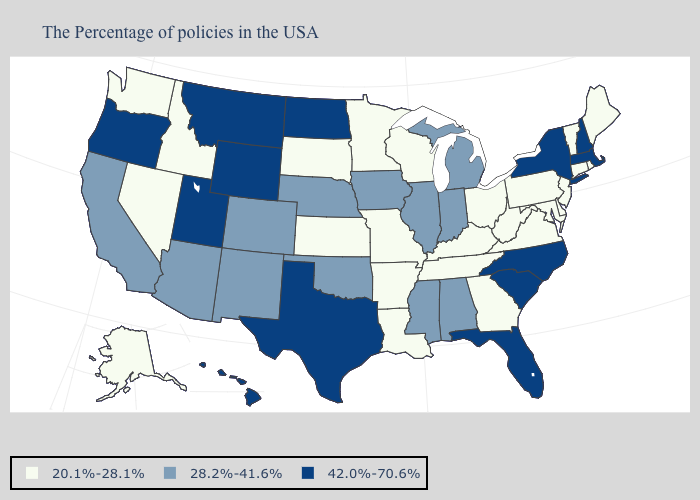Name the states that have a value in the range 20.1%-28.1%?
Concise answer only. Maine, Rhode Island, Vermont, Connecticut, New Jersey, Delaware, Maryland, Pennsylvania, Virginia, West Virginia, Ohio, Georgia, Kentucky, Tennessee, Wisconsin, Louisiana, Missouri, Arkansas, Minnesota, Kansas, South Dakota, Idaho, Nevada, Washington, Alaska. Does Michigan have a lower value than New York?
Be succinct. Yes. Does Michigan have a lower value than Texas?
Give a very brief answer. Yes. Is the legend a continuous bar?
Be succinct. No. Does Oklahoma have the same value as Rhode Island?
Answer briefly. No. Does Delaware have the lowest value in the USA?
Quick response, please. Yes. What is the value of Illinois?
Give a very brief answer. 28.2%-41.6%. Does Utah have the highest value in the West?
Short answer required. Yes. Name the states that have a value in the range 42.0%-70.6%?
Quick response, please. Massachusetts, New Hampshire, New York, North Carolina, South Carolina, Florida, Texas, North Dakota, Wyoming, Utah, Montana, Oregon, Hawaii. Name the states that have a value in the range 28.2%-41.6%?
Concise answer only. Michigan, Indiana, Alabama, Illinois, Mississippi, Iowa, Nebraska, Oklahoma, Colorado, New Mexico, Arizona, California. What is the value of Michigan?
Concise answer only. 28.2%-41.6%. Name the states that have a value in the range 42.0%-70.6%?
Give a very brief answer. Massachusetts, New Hampshire, New York, North Carolina, South Carolina, Florida, Texas, North Dakota, Wyoming, Utah, Montana, Oregon, Hawaii. What is the value of Maine?
Give a very brief answer. 20.1%-28.1%. Name the states that have a value in the range 42.0%-70.6%?
Keep it brief. Massachusetts, New Hampshire, New York, North Carolina, South Carolina, Florida, Texas, North Dakota, Wyoming, Utah, Montana, Oregon, Hawaii. How many symbols are there in the legend?
Short answer required. 3. 